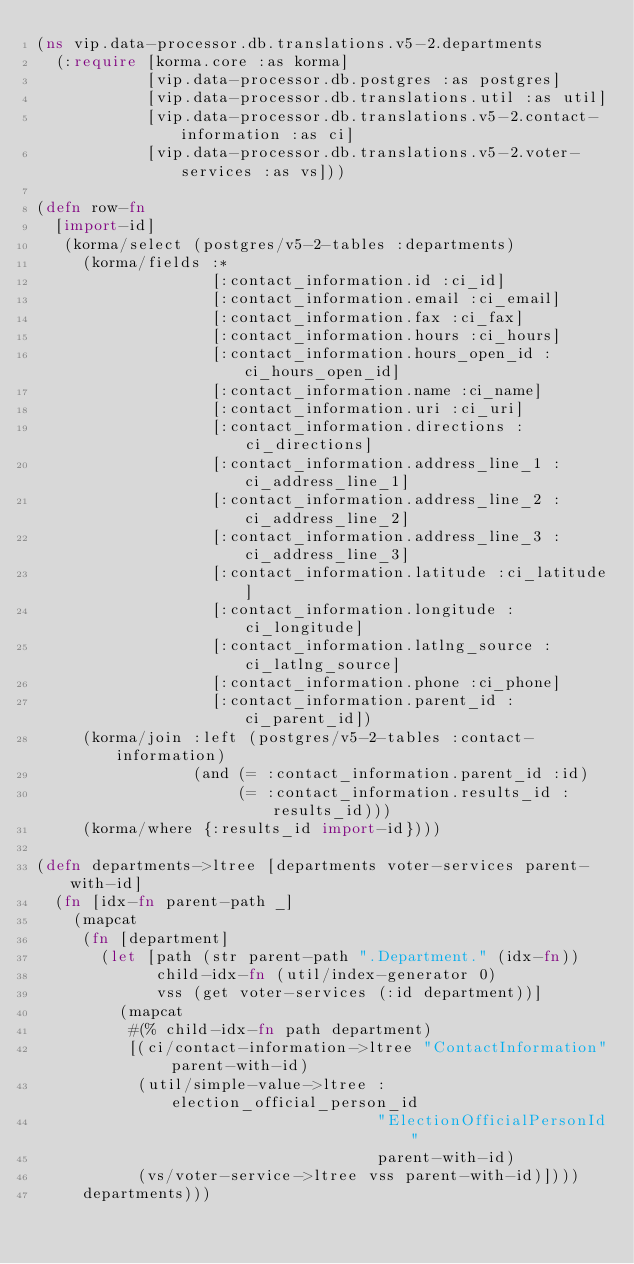Convert code to text. <code><loc_0><loc_0><loc_500><loc_500><_Clojure_>(ns vip.data-processor.db.translations.v5-2.departments
  (:require [korma.core :as korma]
            [vip.data-processor.db.postgres :as postgres]
            [vip.data-processor.db.translations.util :as util]
            [vip.data-processor.db.translations.v5-2.contact-information :as ci]
            [vip.data-processor.db.translations.v5-2.voter-services :as vs]))

(defn row-fn
  [import-id]
   (korma/select (postgres/v5-2-tables :departments)
     (korma/fields :*
                   [:contact_information.id :ci_id]
                   [:contact_information.email :ci_email]
                   [:contact_information.fax :ci_fax]
                   [:contact_information.hours :ci_hours]
                   [:contact_information.hours_open_id :ci_hours_open_id]
                   [:contact_information.name :ci_name]
                   [:contact_information.uri :ci_uri]
                   [:contact_information.directions :ci_directions]
                   [:contact_information.address_line_1 :ci_address_line_1]
                   [:contact_information.address_line_2 :ci_address_line_2]
                   [:contact_information.address_line_3 :ci_address_line_3]
                   [:contact_information.latitude :ci_latitude]
                   [:contact_information.longitude :ci_longitude]
                   [:contact_information.latlng_source :ci_latlng_source]
                   [:contact_information.phone :ci_phone]
                   [:contact_information.parent_id :ci_parent_id])
     (korma/join :left (postgres/v5-2-tables :contact-information)
                 (and (= :contact_information.parent_id :id)
                      (= :contact_information.results_id :results_id)))
     (korma/where {:results_id import-id})))

(defn departments->ltree [departments voter-services parent-with-id]
  (fn [idx-fn parent-path _]
    (mapcat
     (fn [department]
       (let [path (str parent-path ".Department." (idx-fn))
             child-idx-fn (util/index-generator 0)
             vss (get voter-services (:id department))]
         (mapcat
          #(% child-idx-fn path department)
          [(ci/contact-information->ltree "ContactInformation" parent-with-id)
           (util/simple-value->ltree :election_official_person_id
                                     "ElectionOfficialPersonId"
                                     parent-with-id)
           (vs/voter-service->ltree vss parent-with-id)])))
     departments)))
</code> 